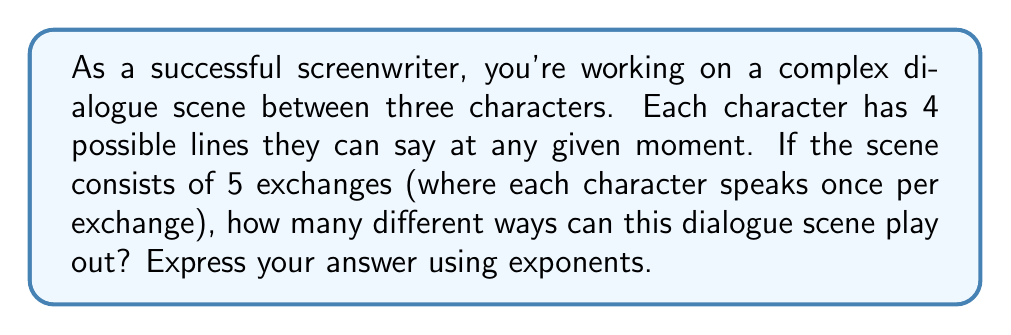Could you help me with this problem? Let's approach this step-by-step:

1) We have three characters, each with 4 possible lines.
2) In each exchange, all three characters speak once.
3) There are 5 exchanges in total.

For each exchange:
- The first character has 4 choices
- The second character has 4 choices
- The third character has 4 choices

So, for a single exchange, the number of possibilities is:

$$ 4 \times 4 \times 4 = 4^3 $$

Now, this happens 5 times (5 exchanges). Each exchange is independent, meaning we multiply the possibilities:

$$ (4^3)^5 $$

This can be simplified using the power rule of exponents $(a^b)^c = a^{bc}$:

$$ 4^{3 \times 5} = 4^{15} $$

Therefore, the total number of possible dialogue combinations for this scene is $4^{15}$.
Answer: $4^{15}$ 